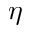<formula> <loc_0><loc_0><loc_500><loc_500>\eta</formula> 